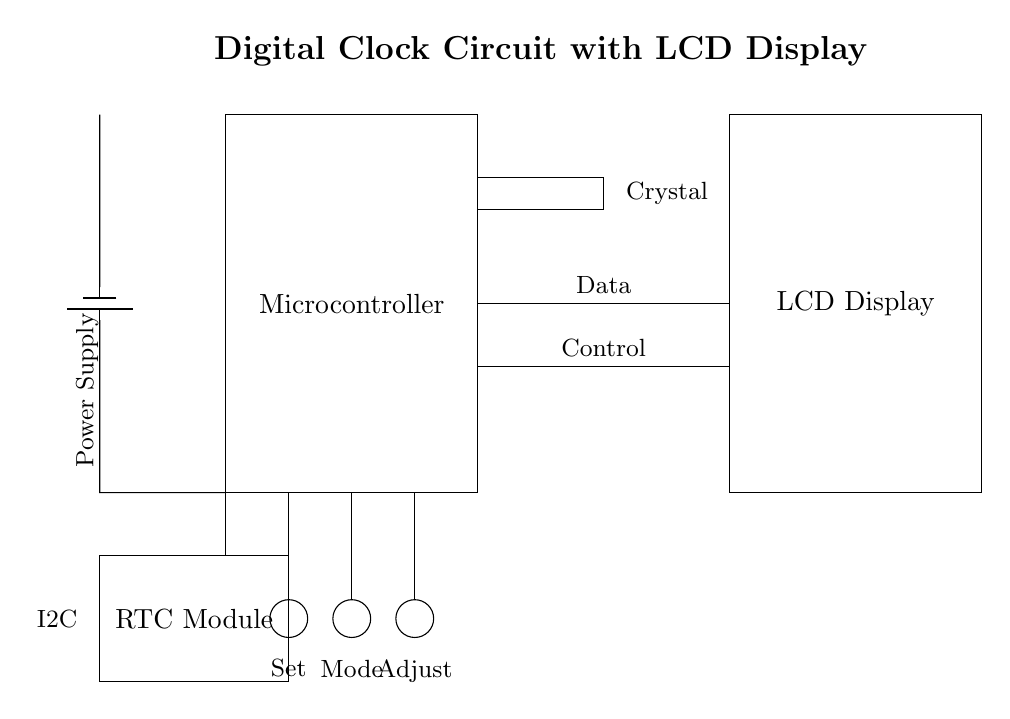What is the main component of this circuit? The main component is the microcontroller, which is indicated at the top of the circuit and serves as the central processing unit for managing the clock.
Answer: Microcontroller What type of display is used in this circuit? The circuit uses an LCD display, as shown in the rectangle at the right side of the diagram, which is responsible for showing the time.
Answer: LCD Display How many buttons are present in the circuit? There are three buttons in the circuit, represented as circles below the microcontroller, labelled Set, Mode, and Adjust.
Answer: Three What protocol does the RTC module utilize? The RTC module is indicated to use the I2C protocol, which is specified in the diagram with a label next to the module.
Answer: I2C What is the purpose of the crystal in the circuit? The crystal oscillator provides a stable clock signal for the microcontroller, ensuring accurate timing for the digital clock. This is inferred from its connection and function in digital timing circuits.
Answer: Accurate timing How do the buttons connect to the microcontroller? The buttons connect to the microcontroller through vertical lines leading from each button to the top, indicating that they provide input directly to the microcontroller.
Answer: Directly Which component powers the entire circuit? The circuit is powered by a battery, which is shown on the left side and is correctly labelled as the power supply in the diagram.
Answer: Battery 